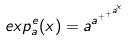Convert formula to latex. <formula><loc_0><loc_0><loc_500><loc_500>e x p _ { a } ^ { e } ( x ) = a ^ { a ^ { + ^ { + ^ { a ^ { x } } } } }</formula> 